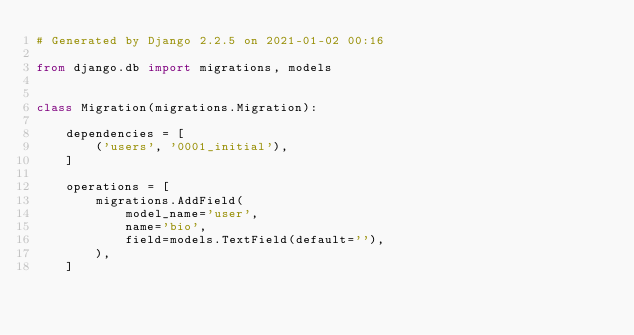Convert code to text. <code><loc_0><loc_0><loc_500><loc_500><_Python_># Generated by Django 2.2.5 on 2021-01-02 00:16

from django.db import migrations, models


class Migration(migrations.Migration):

    dependencies = [
        ('users', '0001_initial'),
    ]

    operations = [
        migrations.AddField(
            model_name='user',
            name='bio',
            field=models.TextField(default=''),
        ),
    ]
</code> 